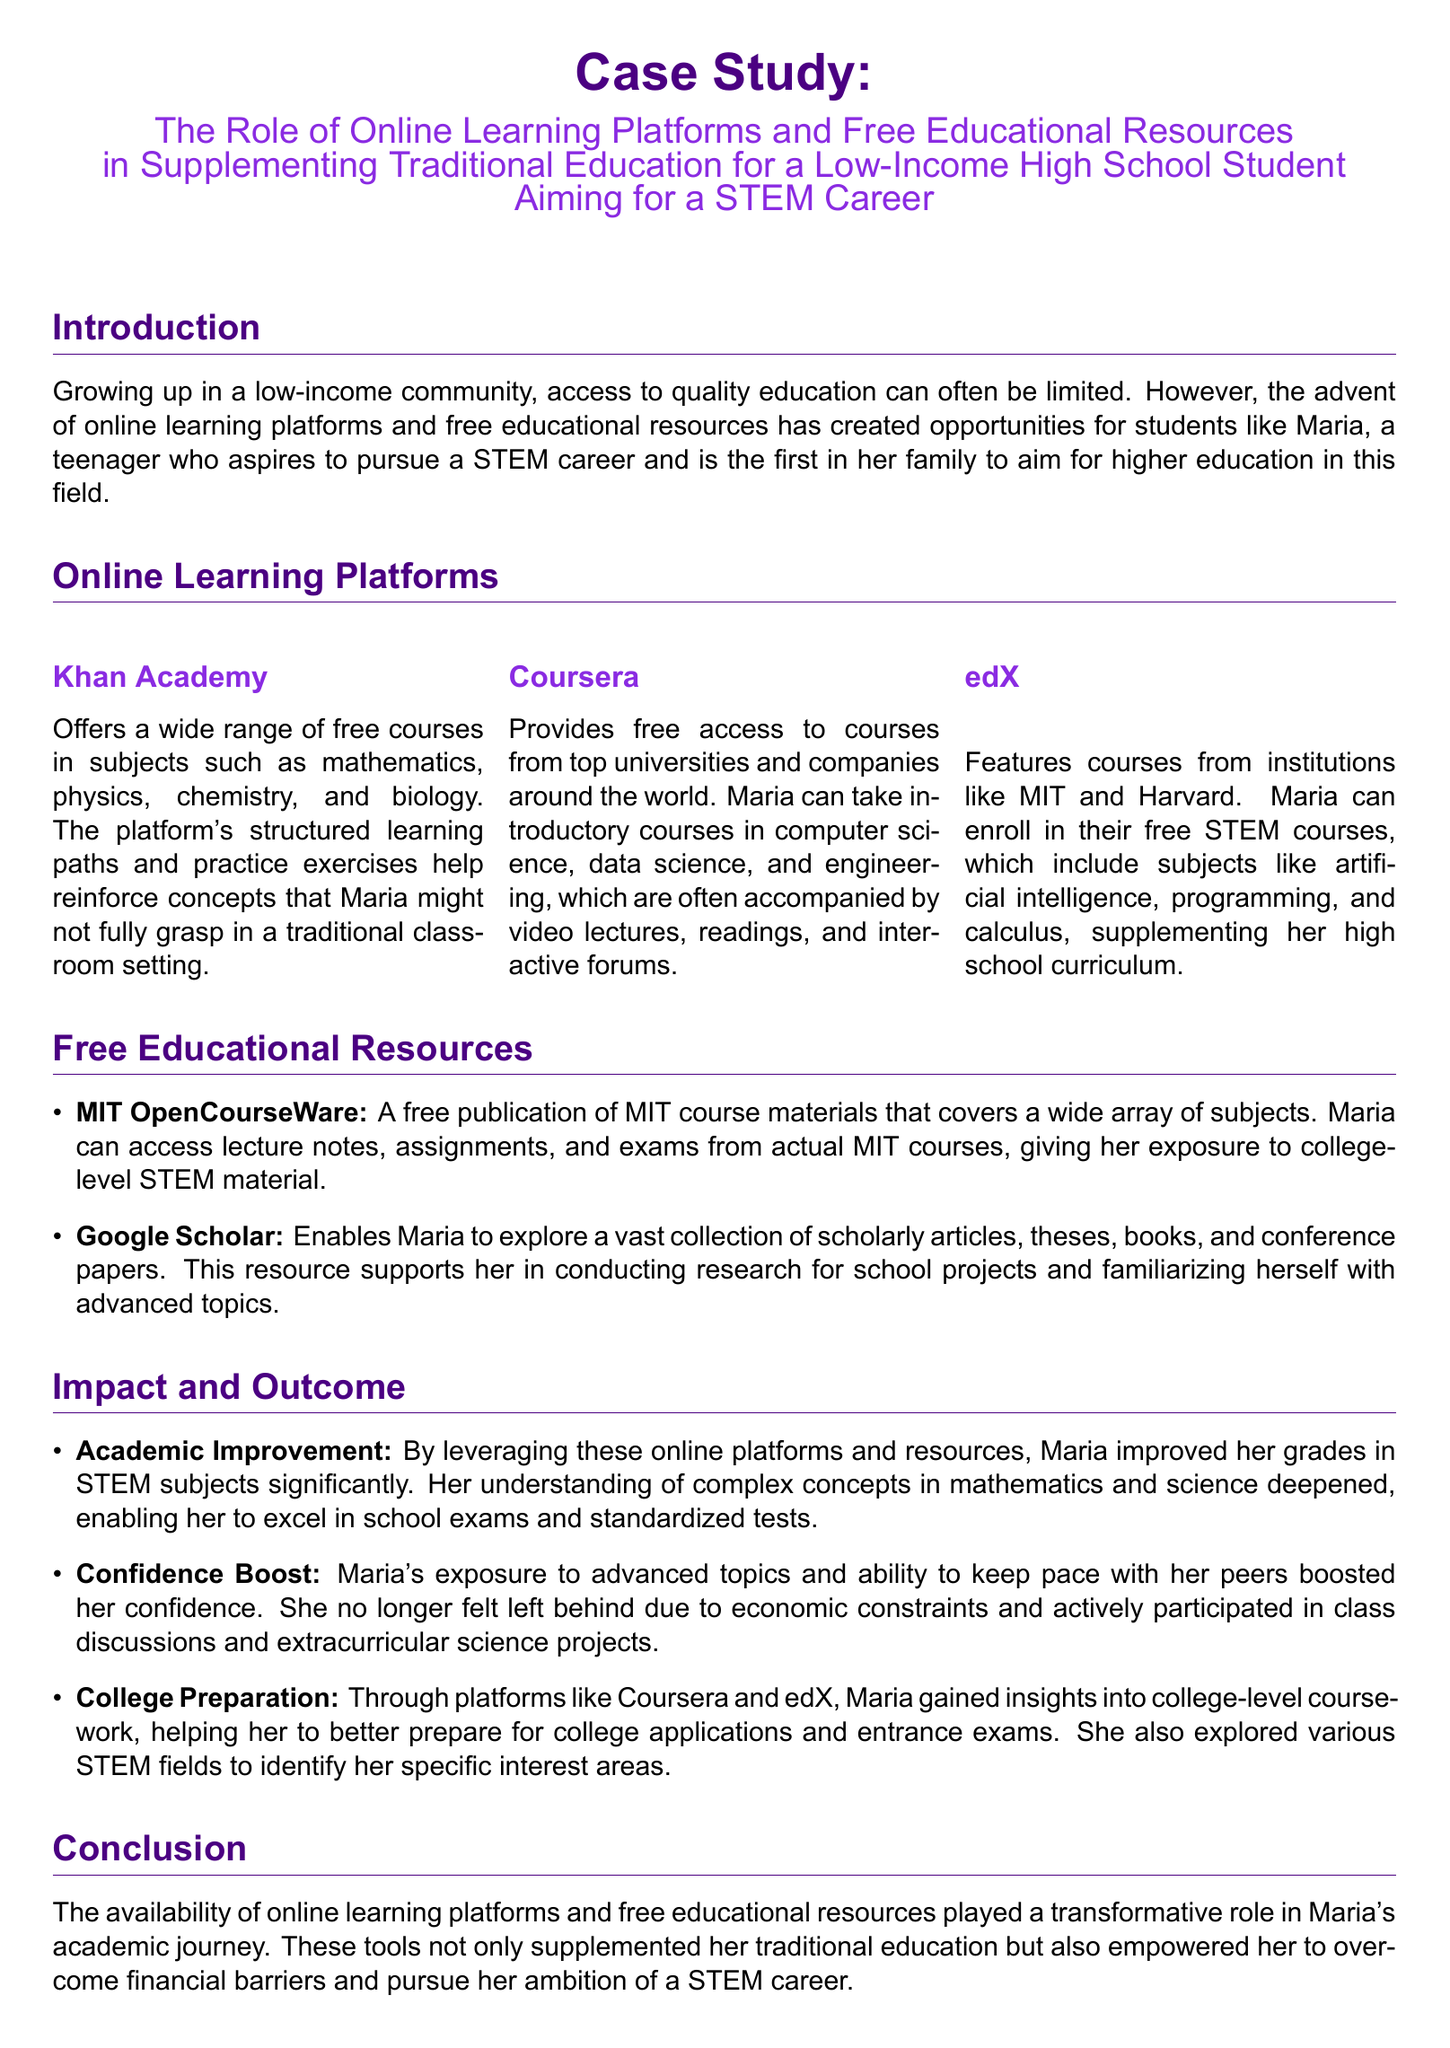What is Maria's goal? The document states that Maria aspires to pursue a STEM career.
Answer: STEM career What platform offers free access to courses from top universities? The document mentions Coursera as a platform providing courses from top universities.
Answer: Coursera Which educational resource allows Maria to explore scholarly articles? The document indicates that Google Scholar enables Maria to explore scholarly articles.
Answer: Google Scholar What was one impact on Maria's academic performance? The document notes that Maria improved her grades in STEM subjects significantly.
Answer: Improved grades Which institution's course materials can Maria access for free? The document states that MIT OpenCourseWare is a source of free course materials.
Answer: MIT What type of courses does edX feature? The document indicates that edX features courses from institutions like MIT and Harvard.
Answer: Courses from institutions like MIT and Harvard How did online resources affect Maria's confidence? The document mentions that her exposure to advanced topics boosted her confidence.
Answer: Boosted her confidence What type of projects did Maria actively participate in? The document specifies that Maria participated in extracurricular science projects.
Answer: Extracurricular science projects 